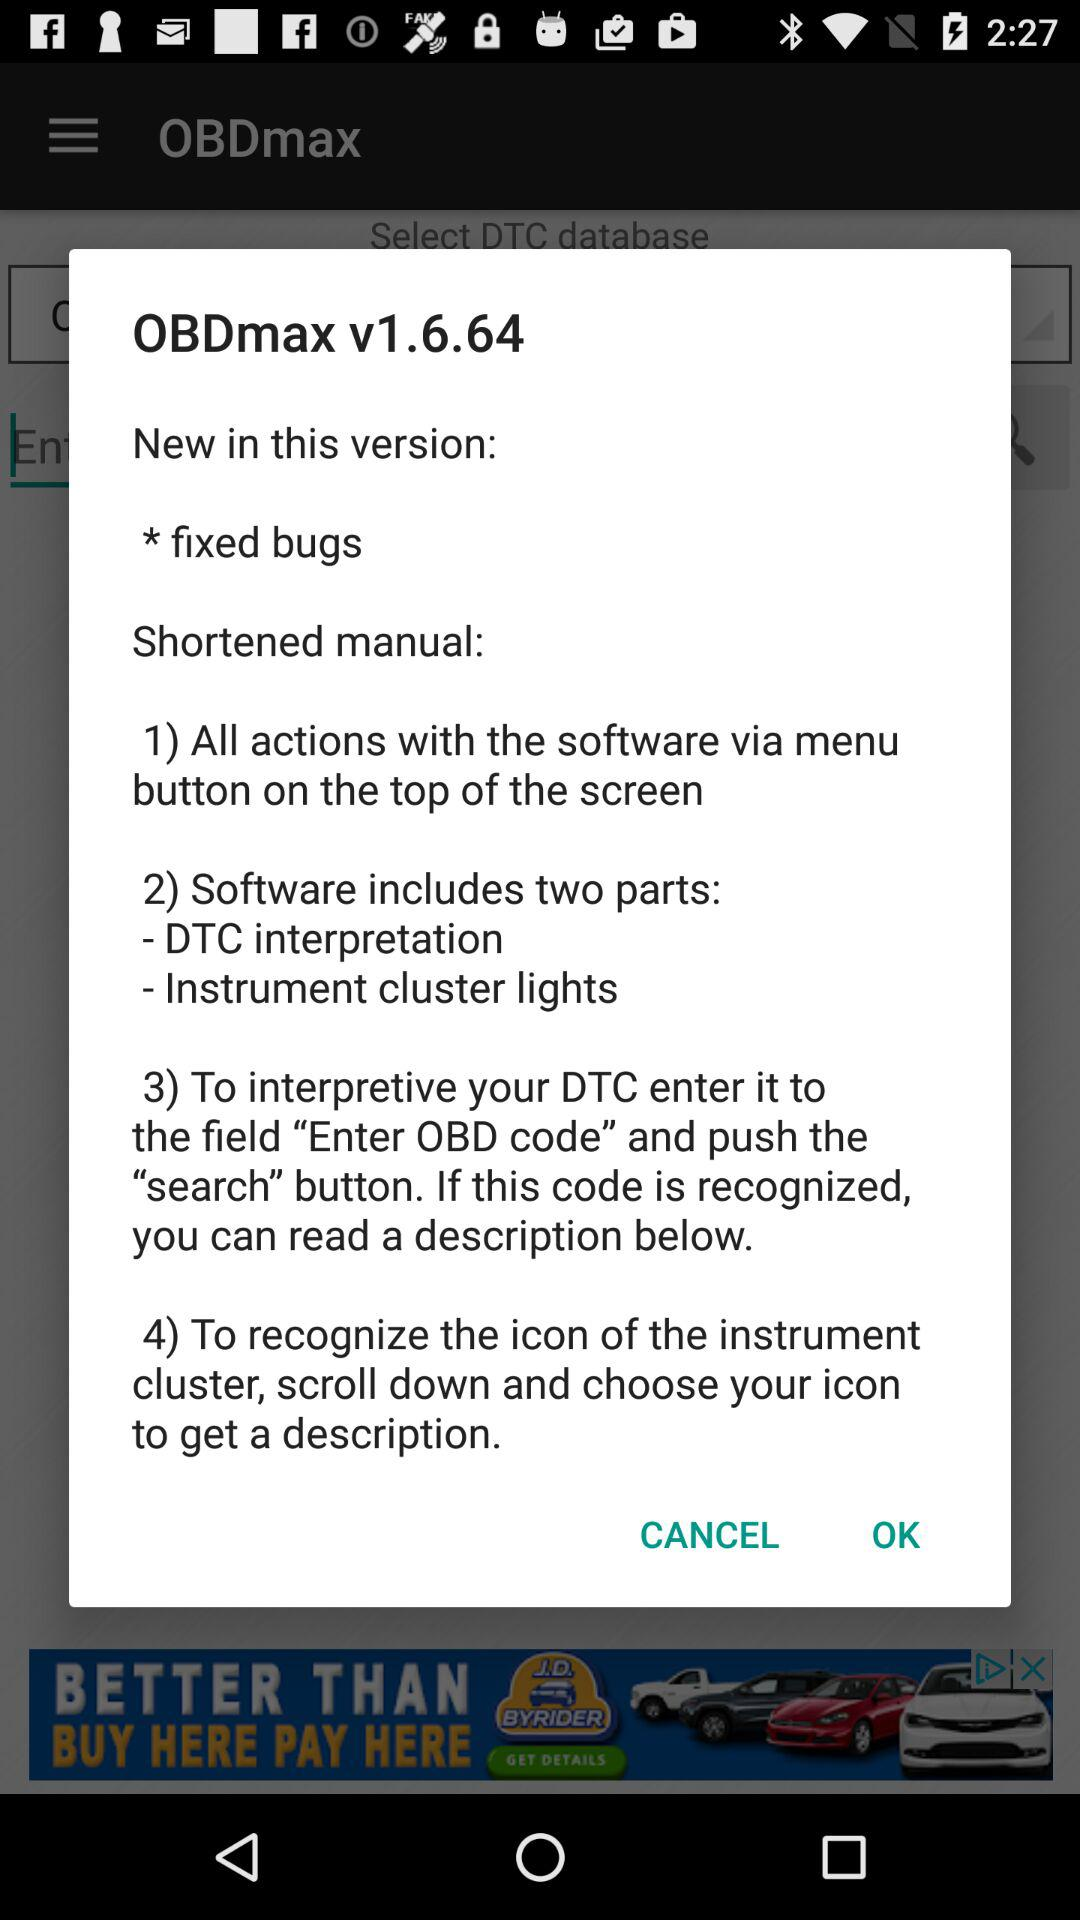How many steps are there in the shortened manual?
Answer the question using a single word or phrase. 4 